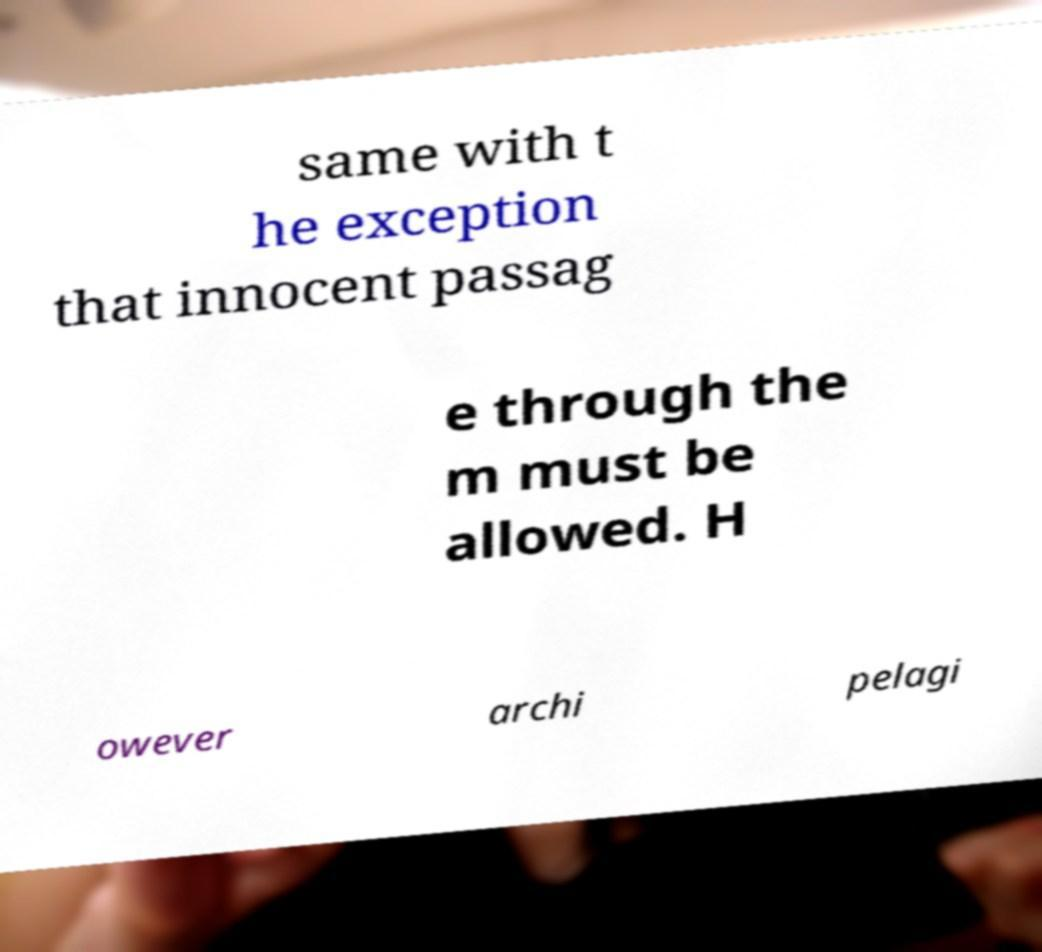Could you assist in decoding the text presented in this image and type it out clearly? same with t he exception that innocent passag e through the m must be allowed. H owever archi pelagi 